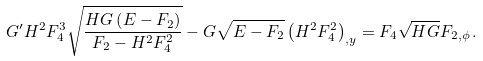<formula> <loc_0><loc_0><loc_500><loc_500>G ^ { \prime } H ^ { 2 } F _ { 4 } ^ { 3 } \sqrt { \frac { H G \left ( E - F _ { 2 } \right ) } { F _ { 2 } - H ^ { 2 } F _ { 4 } ^ { 2 } } } - G \sqrt { E - F _ { 2 } } \left ( H ^ { 2 } F _ { 4 } ^ { 2 } \right ) _ { , y } = F _ { 4 } \sqrt { H G } F _ { 2 , \phi } \, .</formula> 